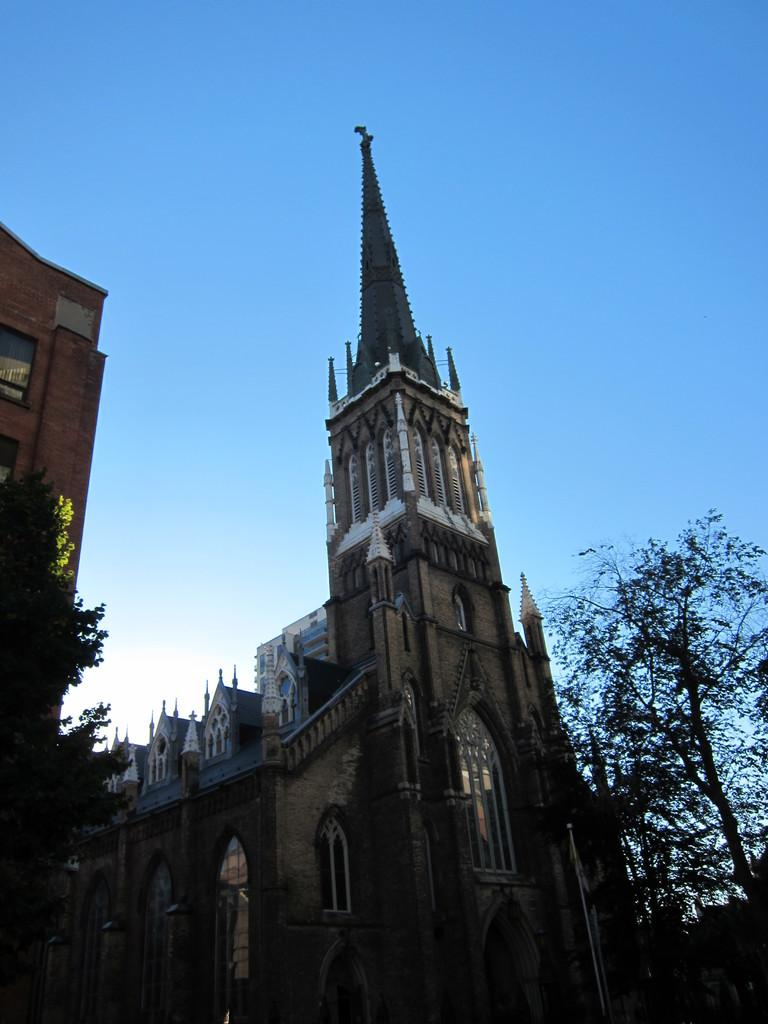Where was the picture taken? The picture was taken outside a city. What can be seen in the foreground of the image? There are trees and buildings in the foreground of the image. What is the condition of the sky in the image? The sky is clear in the image. What advice does the mom give about the weather in the image? There is no mom present in the image, and therefore no advice about the weather can be given. 